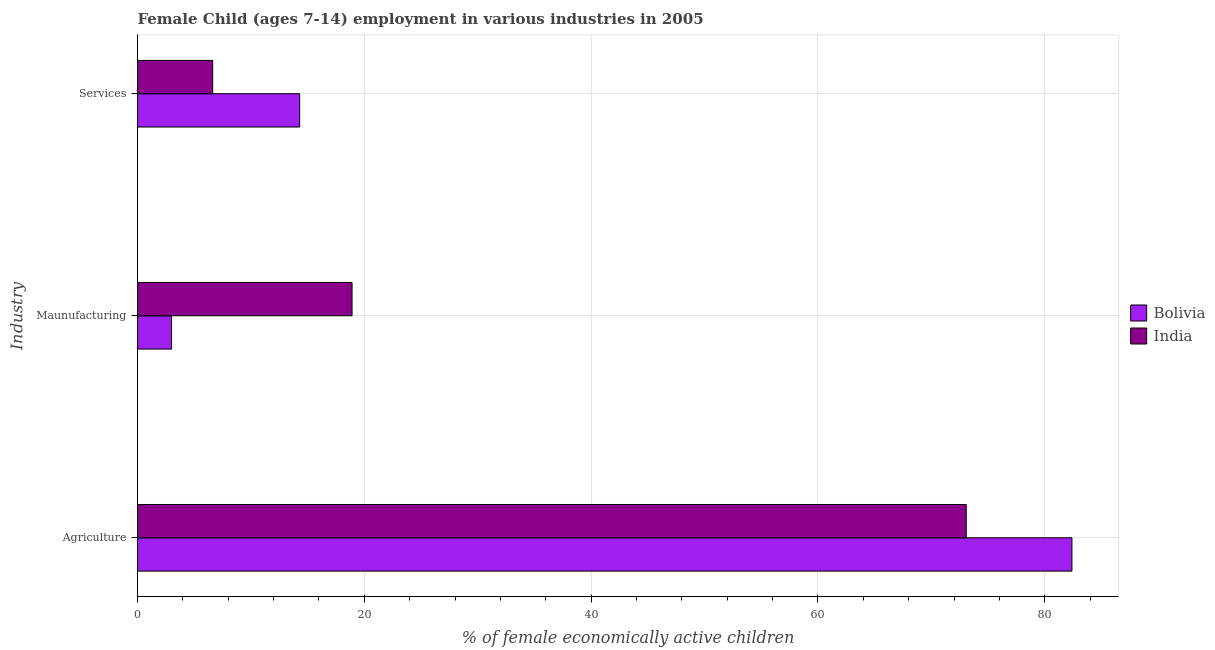How many different coloured bars are there?
Provide a short and direct response. 2. How many groups of bars are there?
Provide a short and direct response. 3. What is the label of the 3rd group of bars from the top?
Provide a succinct answer. Agriculture. What is the percentage of economically active children in services in India?
Provide a short and direct response. 6.63. Across all countries, what is the minimum percentage of economically active children in manufacturing?
Keep it short and to the point. 3. What is the total percentage of economically active children in services in the graph?
Your response must be concise. 20.93. What is the difference between the percentage of economically active children in services in Bolivia and that in India?
Your answer should be compact. 7.67. What is the difference between the percentage of economically active children in agriculture in India and the percentage of economically active children in services in Bolivia?
Offer a terse response. 58.78. What is the average percentage of economically active children in services per country?
Your response must be concise. 10.46. What is the difference between the percentage of economically active children in services and percentage of economically active children in manufacturing in India?
Provide a short and direct response. -12.29. In how many countries, is the percentage of economically active children in services greater than 4 %?
Offer a terse response. 2. What is the ratio of the percentage of economically active children in agriculture in India to that in Bolivia?
Offer a terse response. 0.89. Is the difference between the percentage of economically active children in services in India and Bolivia greater than the difference between the percentage of economically active children in manufacturing in India and Bolivia?
Keep it short and to the point. No. What is the difference between the highest and the second highest percentage of economically active children in services?
Your response must be concise. 7.67. What is the difference between the highest and the lowest percentage of economically active children in manufacturing?
Your response must be concise. 15.92. Is the sum of the percentage of economically active children in manufacturing in Bolivia and India greater than the maximum percentage of economically active children in agriculture across all countries?
Ensure brevity in your answer.  No. What does the 2nd bar from the top in Agriculture represents?
Provide a short and direct response. Bolivia. What does the 2nd bar from the bottom in Services represents?
Give a very brief answer. India. Are all the bars in the graph horizontal?
Keep it short and to the point. Yes. What is the difference between two consecutive major ticks on the X-axis?
Offer a terse response. 20. Are the values on the major ticks of X-axis written in scientific E-notation?
Make the answer very short. No. Does the graph contain any zero values?
Provide a succinct answer. No. What is the title of the graph?
Provide a succinct answer. Female Child (ages 7-14) employment in various industries in 2005. What is the label or title of the X-axis?
Keep it short and to the point. % of female economically active children. What is the label or title of the Y-axis?
Keep it short and to the point. Industry. What is the % of female economically active children in Bolivia in Agriculture?
Provide a short and direct response. 82.4. What is the % of female economically active children in India in Agriculture?
Offer a terse response. 73.08. What is the % of female economically active children in India in Maunufacturing?
Your answer should be very brief. 18.92. What is the % of female economically active children of India in Services?
Your answer should be compact. 6.63. Across all Industry, what is the maximum % of female economically active children of Bolivia?
Provide a succinct answer. 82.4. Across all Industry, what is the maximum % of female economically active children of India?
Offer a very short reply. 73.08. Across all Industry, what is the minimum % of female economically active children in Bolivia?
Provide a short and direct response. 3. Across all Industry, what is the minimum % of female economically active children in India?
Ensure brevity in your answer.  6.63. What is the total % of female economically active children in Bolivia in the graph?
Keep it short and to the point. 99.7. What is the total % of female economically active children of India in the graph?
Ensure brevity in your answer.  98.63. What is the difference between the % of female economically active children in Bolivia in Agriculture and that in Maunufacturing?
Provide a short and direct response. 79.4. What is the difference between the % of female economically active children in India in Agriculture and that in Maunufacturing?
Your answer should be very brief. 54.16. What is the difference between the % of female economically active children of Bolivia in Agriculture and that in Services?
Offer a very short reply. 68.1. What is the difference between the % of female economically active children in India in Agriculture and that in Services?
Your response must be concise. 66.45. What is the difference between the % of female economically active children of India in Maunufacturing and that in Services?
Your answer should be very brief. 12.29. What is the difference between the % of female economically active children in Bolivia in Agriculture and the % of female economically active children in India in Maunufacturing?
Your answer should be very brief. 63.48. What is the difference between the % of female economically active children in Bolivia in Agriculture and the % of female economically active children in India in Services?
Ensure brevity in your answer.  75.77. What is the difference between the % of female economically active children in Bolivia in Maunufacturing and the % of female economically active children in India in Services?
Your response must be concise. -3.63. What is the average % of female economically active children in Bolivia per Industry?
Ensure brevity in your answer.  33.23. What is the average % of female economically active children of India per Industry?
Keep it short and to the point. 32.88. What is the difference between the % of female economically active children in Bolivia and % of female economically active children in India in Agriculture?
Your response must be concise. 9.32. What is the difference between the % of female economically active children in Bolivia and % of female economically active children in India in Maunufacturing?
Keep it short and to the point. -15.92. What is the difference between the % of female economically active children of Bolivia and % of female economically active children of India in Services?
Keep it short and to the point. 7.67. What is the ratio of the % of female economically active children of Bolivia in Agriculture to that in Maunufacturing?
Offer a terse response. 27.47. What is the ratio of the % of female economically active children in India in Agriculture to that in Maunufacturing?
Ensure brevity in your answer.  3.86. What is the ratio of the % of female economically active children of Bolivia in Agriculture to that in Services?
Your answer should be very brief. 5.76. What is the ratio of the % of female economically active children of India in Agriculture to that in Services?
Make the answer very short. 11.02. What is the ratio of the % of female economically active children in Bolivia in Maunufacturing to that in Services?
Provide a short and direct response. 0.21. What is the ratio of the % of female economically active children of India in Maunufacturing to that in Services?
Your answer should be compact. 2.85. What is the difference between the highest and the second highest % of female economically active children in Bolivia?
Offer a terse response. 68.1. What is the difference between the highest and the second highest % of female economically active children in India?
Your answer should be very brief. 54.16. What is the difference between the highest and the lowest % of female economically active children of Bolivia?
Your response must be concise. 79.4. What is the difference between the highest and the lowest % of female economically active children of India?
Your answer should be compact. 66.45. 